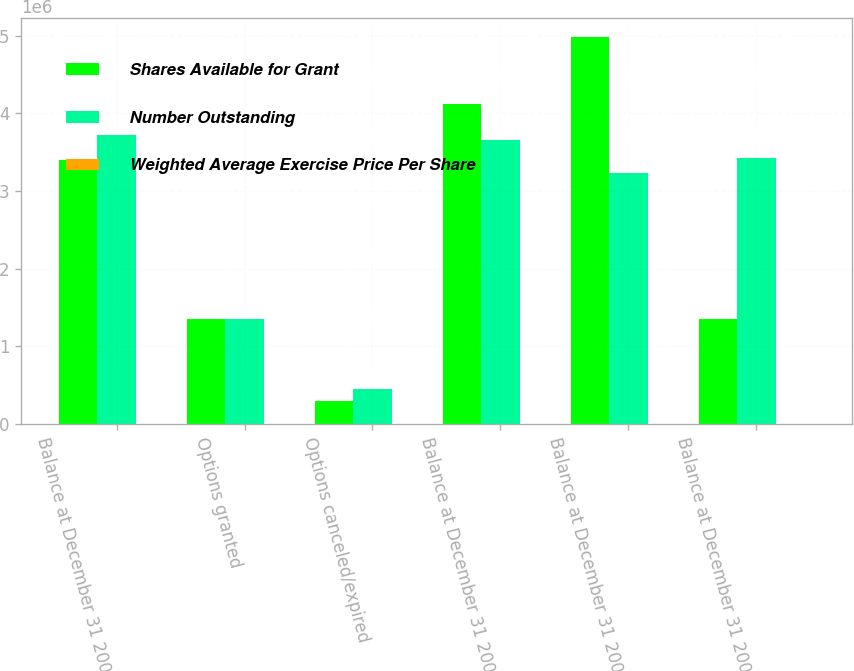Convert chart to OTSL. <chart><loc_0><loc_0><loc_500><loc_500><stacked_bar_chart><ecel><fcel>Balance at December 31 2003<fcel>Options granted<fcel>Options canceled/expired<fcel>Balance at December 31 2004<fcel>Balance at December 31 2005<fcel>Balance at December 31 2006<nl><fcel>Shares Available for Grant<fcel>3.39989e+06<fcel>1.3508e+06<fcel>296078<fcel>4.12218e+06<fcel>4.98135e+06<fcel>1.3508e+06<nl><fcel>Number Outstanding<fcel>3.72543e+06<fcel>1.3508e+06<fcel>446493<fcel>3.6618e+06<fcel>3.23168e+06<fcel>3.42768e+06<nl><fcel>Weighted Average Exercise Price Per Share<fcel>14.5<fcel>19.14<fcel>21.34<fcel>16.2<fcel>28.93<fcel>50.1<nl></chart> 